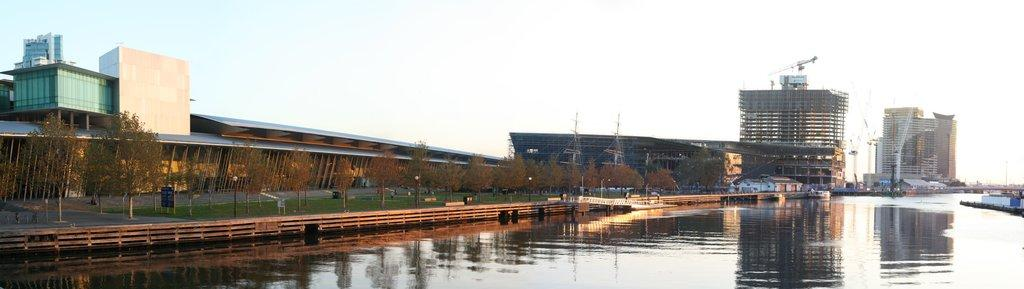What type of structures can be seen in the image? There are buildings in the image. What natural elements are present in the image? There are trees and grass in the image. What type of barrier can be seen in the image? There is a fence in the image. What body of water is visible in the image? There is water visible in the image. What type of infrastructure is present in the image? There are electrical poles in the image. What part of the natural environment is visible in the background of the image? The sky is visible in the background of the image. How many snails can be seen crawling on the mouth of the question in the image? There are no snails or questions present in the image. What type of creature is shown interacting with the mouth of the question in the image? There is no creature or question present in the image. 